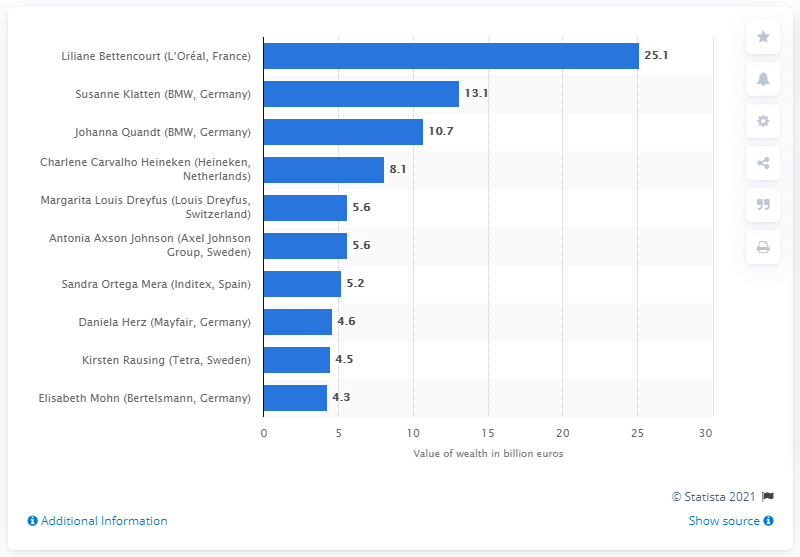Give some essential details in this illustration. Liliane Bettencourt's personal fortune was estimated to be 25.1 billion dollars at the time of her death. 